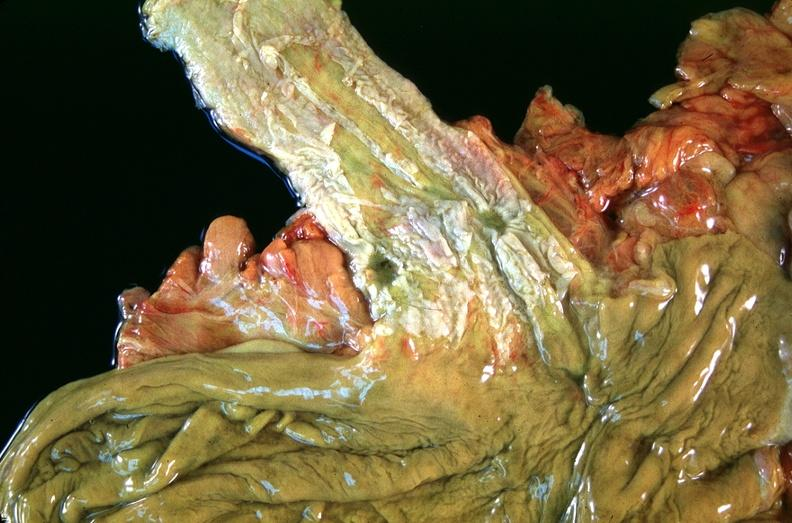where does this belong to?
Answer the question using a single word or phrase. Gastrointestinal system 